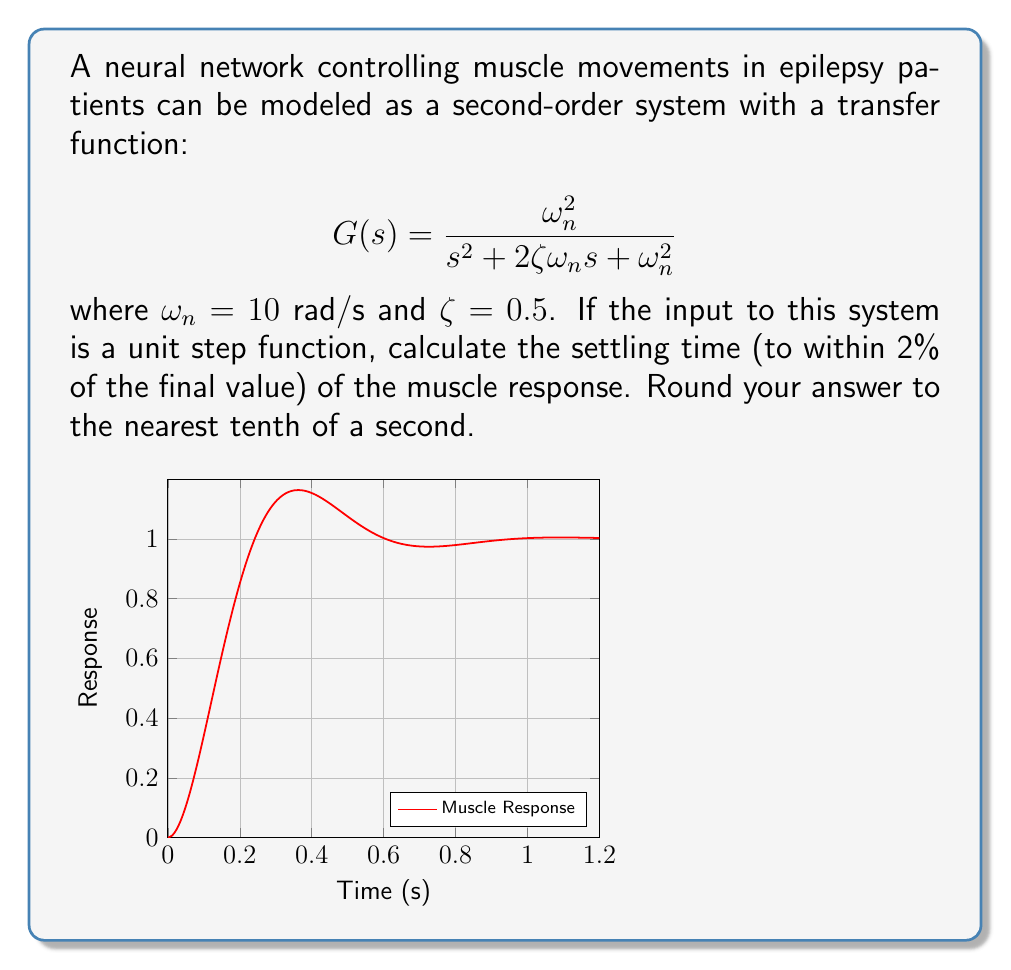Could you help me with this problem? To solve this problem, we'll follow these steps:

1) The settling time for a second-order system is given by the formula:

   $$T_s \approx \frac{4}{\zeta\omega_n}$$

2) We're given that $\omega_n = 10$ rad/s and $\zeta = 0.5$

3) Let's substitute these values into the formula:

   $$T_s \approx \frac{4}{0.5 \cdot 10}$$

4) Simplify:
   
   $$T_s \approx \frac{4}{5} = 0.8\text{ seconds}$$

5) The question asks to round to the nearest tenth of a second, so our final answer is 0.8 seconds.

This settling time indicates that after approximately 0.8 seconds, the muscle response will remain within 2% of its final value, which is crucial information for understanding and managing muscle control in epilepsy patients.
Answer: 0.8 seconds 